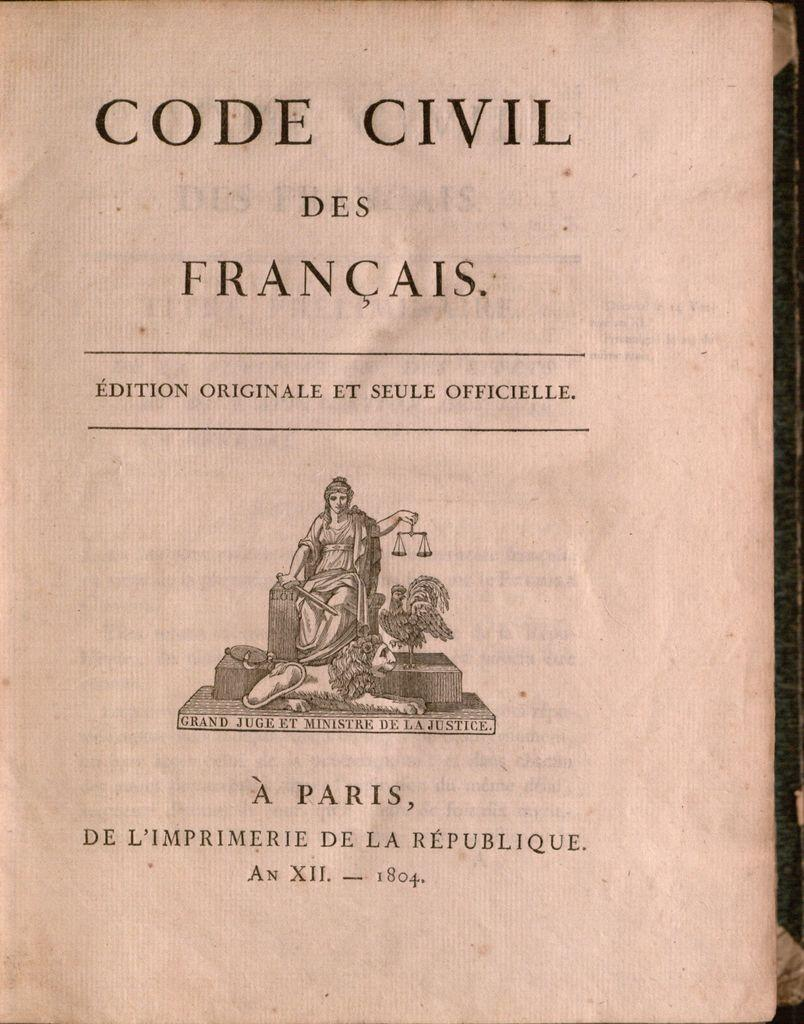<image>
Render a clear and concise summary of the photo. A book called Code Civil Des Francais by A Paris. 